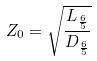<formula> <loc_0><loc_0><loc_500><loc_500>Z _ { 0 } = \sqrt { \frac { L _ { \frac { 6 } { 5 } } } { D _ { \frac { 6 } { 5 } } } }</formula> 